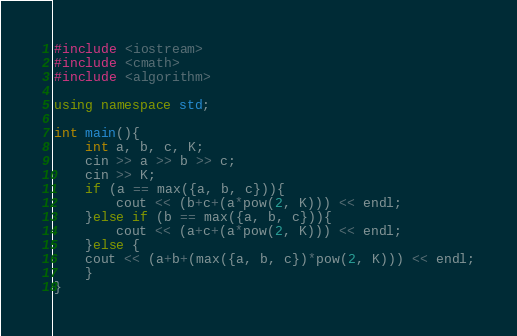Convert code to text. <code><loc_0><loc_0><loc_500><loc_500><_C++_>#include <iostream>
#include <cmath>
#include <algorithm>
 
using namespace std;
 
int main(){
    int a, b, c, K;
    cin >> a >> b >> c;
    cin >> K;
    if (a == max({a, b, c})){
        cout << (b+c+(a*pow(2, K))) << endl;
    }else if (b == max({a, b, c})){
        cout << (a+c+(a*pow(2, K))) << endl;
    }else {
    cout << (a+b+(max({a, b, c})*pow(2, K))) << endl;
    }
}</code> 